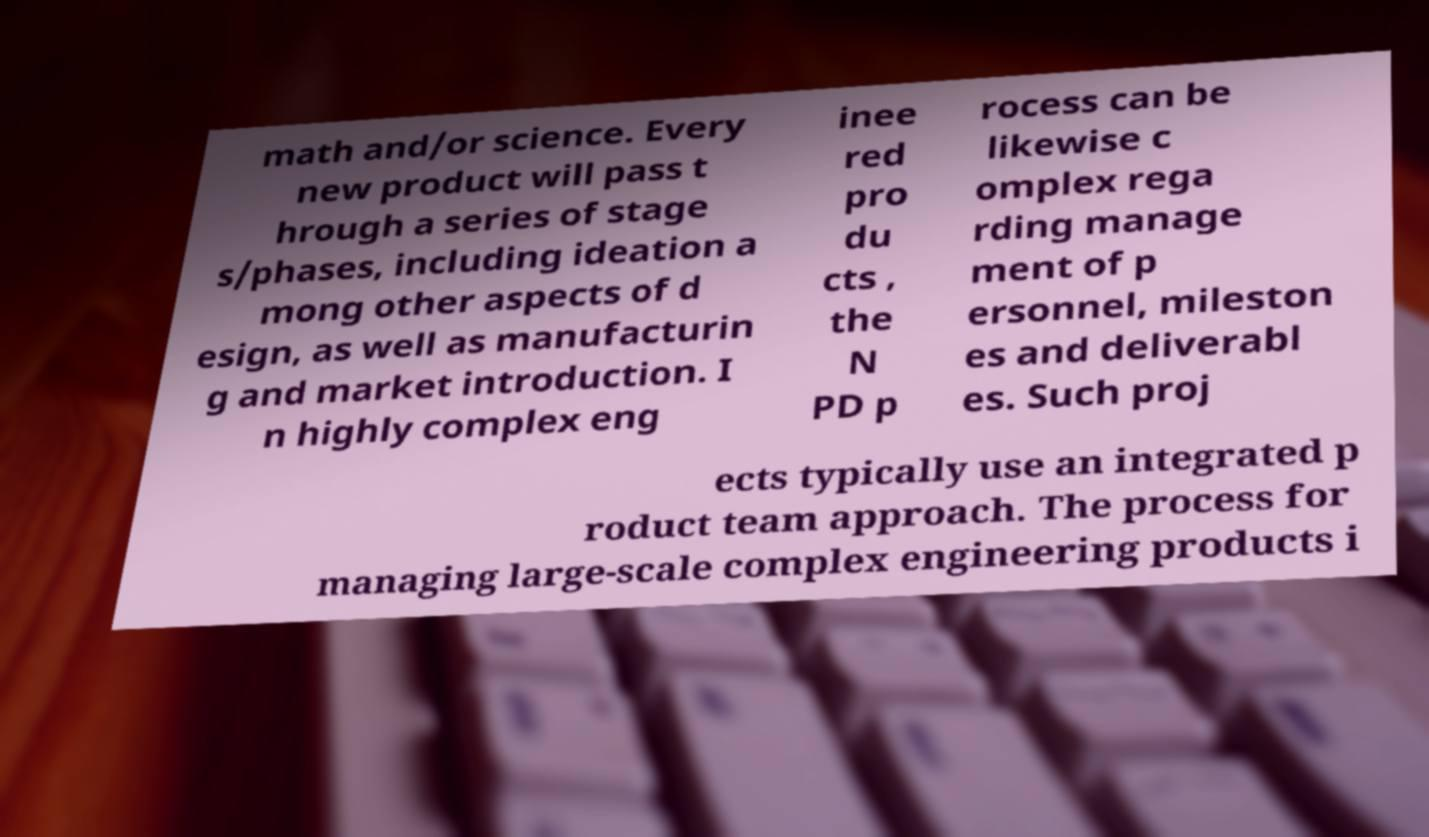Could you extract and type out the text from this image? math and/or science. Every new product will pass t hrough a series of stage s/phases, including ideation a mong other aspects of d esign, as well as manufacturin g and market introduction. I n highly complex eng inee red pro du cts , the N PD p rocess can be likewise c omplex rega rding manage ment of p ersonnel, mileston es and deliverabl es. Such proj ects typically use an integrated p roduct team approach. The process for managing large-scale complex engineering products i 